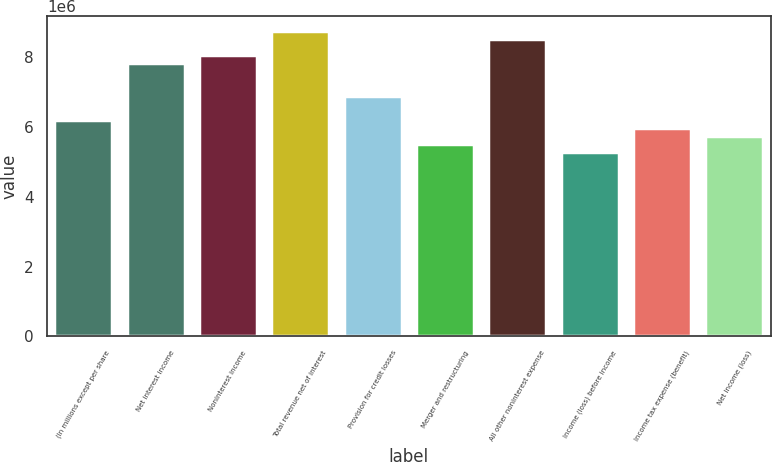Convert chart to OTSL. <chart><loc_0><loc_0><loc_500><loc_500><bar_chart><fcel>(In millions except per share<fcel>Net interest income<fcel>Noninterest income<fcel>Total revenue net of interest<fcel>Provision for credit losses<fcel>Merger and restructuring<fcel>All other noninterest expense<fcel>Income (loss) before income<fcel>Income tax expense (benefit)<fcel>Net income (loss)<nl><fcel>6.20007e+06<fcel>7.80749e+06<fcel>8.03713e+06<fcel>8.72602e+06<fcel>6.88897e+06<fcel>5.51117e+06<fcel>8.49639e+06<fcel>5.28154e+06<fcel>5.97044e+06<fcel>5.74081e+06<nl></chart> 